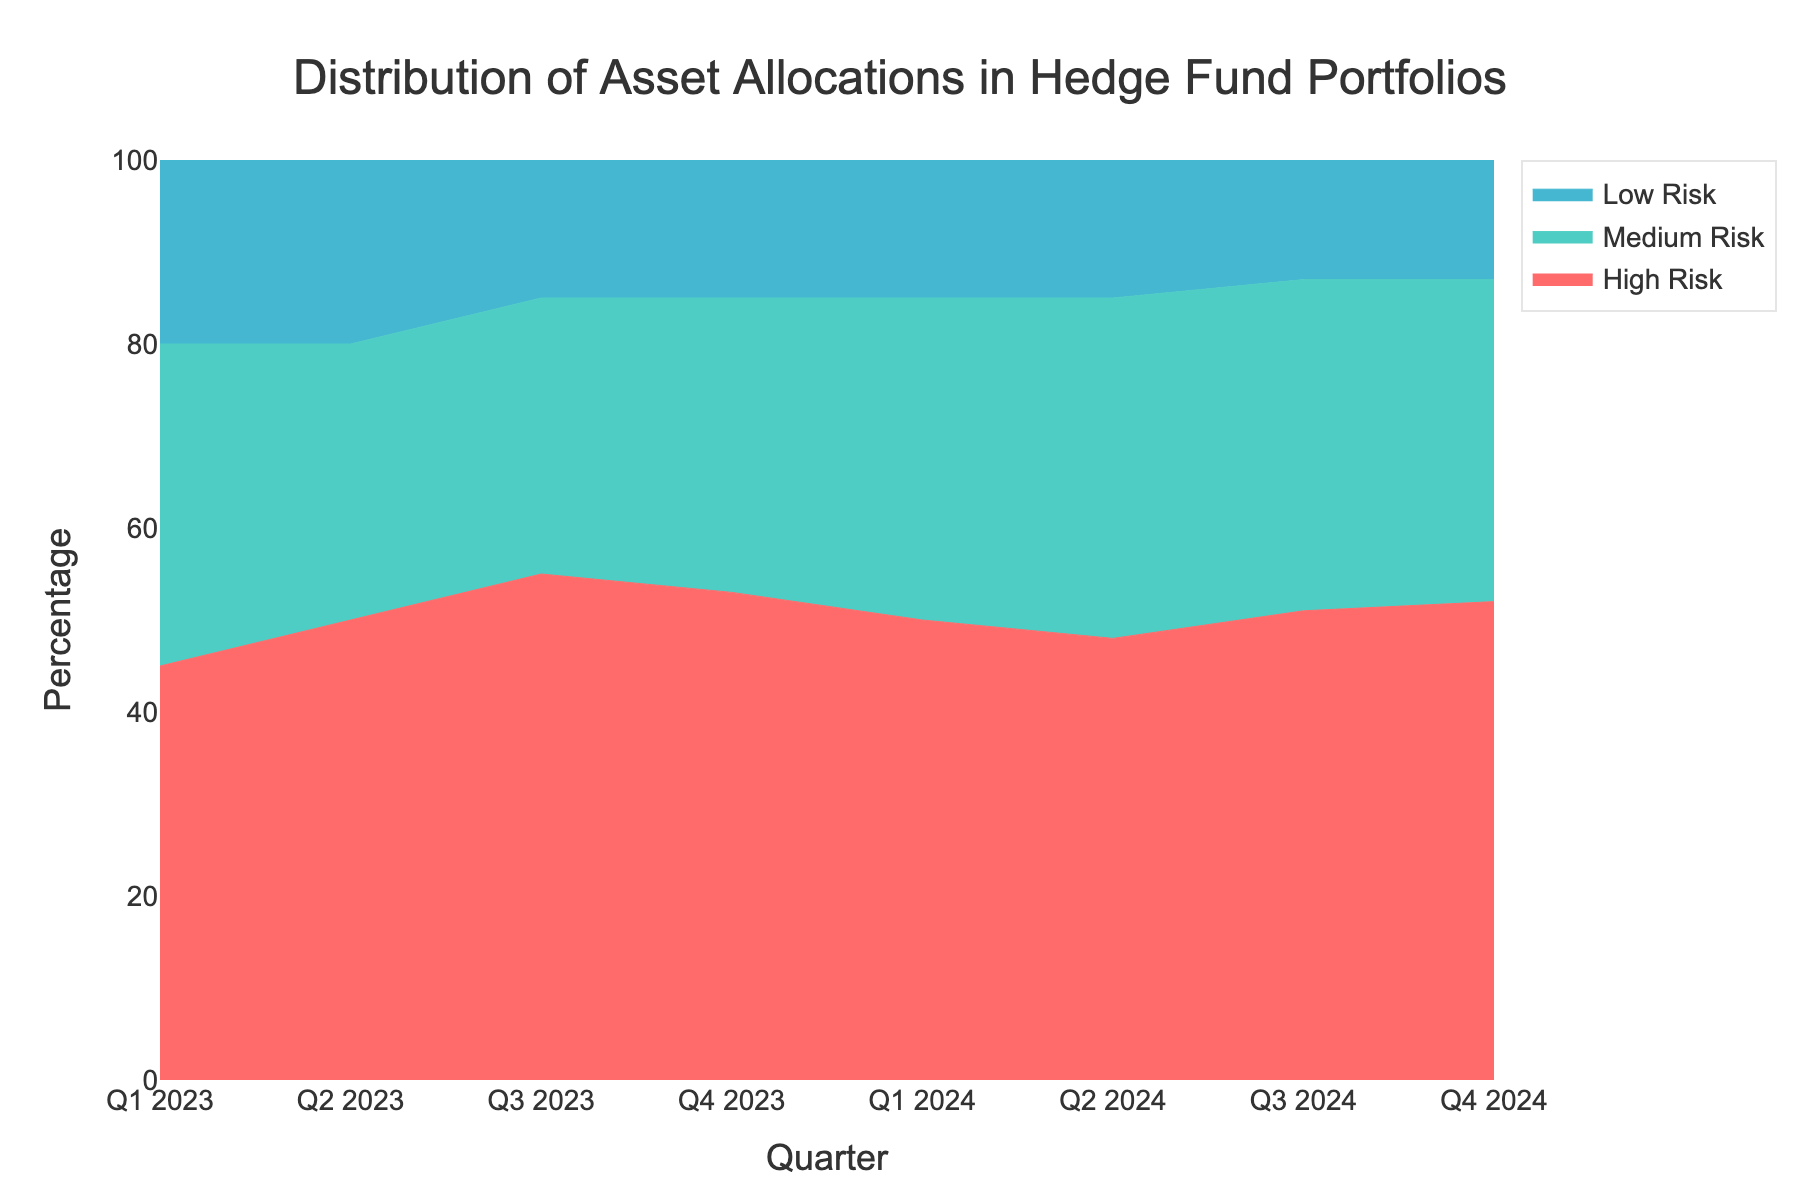What is the title of the figure? The title of the figure is indicated at the top of the visual and provides a summary of what the chart is about
Answer: Distribution of Asset Allocations in Hedge Fund Portfolios What is the percentage of High Risk assets in Q2 2024? To find this information, locate Q2 2024 on the x-axis and look at the High Risk area which is usually the topmost segment in the stack
Answer: 48% Which quarter shows the highest percentage allocation in Medium Risk assets? To determine this, observe the Medium Risk segments across all quarters on the x-axis and note which has the greatest height
Answer: Q2 2024 How did the percentage of Low Risk assets change from Q1 2023 to Q4 2024? Compare the heights of the Low Risk segments in Q1 2023 and Q4 2024 by observing the bottommost segment in the stack
Answer: Decreased by 7% What is the overall trend in the percentage of High Risk assets from Q1 2023 to Q4 2024? Observe the movement of the High Risk segments across all quarters from left to right in the chart to identify the pattern over time
Answer: Generally increasing In which quarter did the combined percentage of Medium and Low Risk assets peak? For this, calculate the sum of Medium and Low Risk percentages for each quarter and compare them
Answer: Q3 2024 How does the sum of High and Medium Risk percentages in Q1 2024 compare to Q2 2024? Add the High Risk and Medium Risk percentages for Q1 2024 and Q2 2024 separately and then compare the sums
Answer: Higher in Q2 2024 What is the range of percentages for Low Risk assets observed in the chart? Identify the minimum and maximum percentages of Low Risk assets across all quarters observed in the chart to determine the range
Answer: 13% - 20% Between which consecutive quarters did the percentage of High Risk assets increase the most? Compare the difference in High Risk asset percentages between all pairs of consecutive quarters to find the largest increase
Answer: Q2 2023 to Q3 2023 What remains constant for Low Risk assets from Q2 2023 to Q4 2024? Observe if there is any repeating pattern or consistent value for Low Risk assets within the specified period from the chart
Answer: 15% 